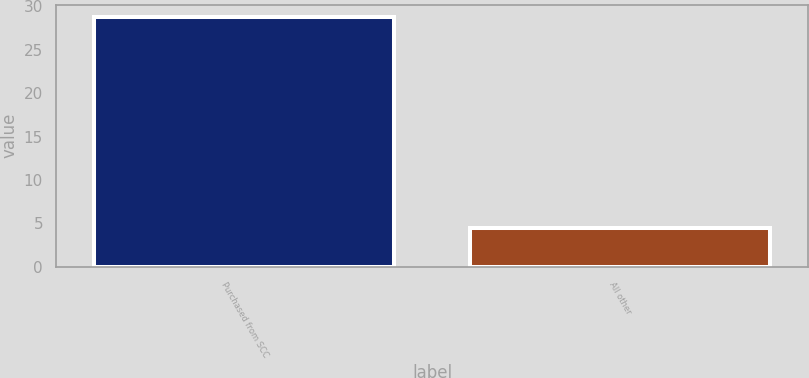Convert chart to OTSL. <chart><loc_0><loc_0><loc_500><loc_500><bar_chart><fcel>Purchased from SCC<fcel>All other<nl><fcel>28.74<fcel>4.44<nl></chart> 